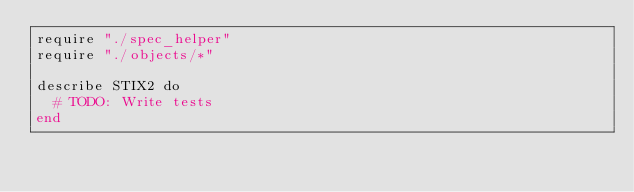Convert code to text. <code><loc_0><loc_0><loc_500><loc_500><_Crystal_>require "./spec_helper"
require "./objects/*"

describe STIX2 do
  # TODO: Write tests
end
</code> 